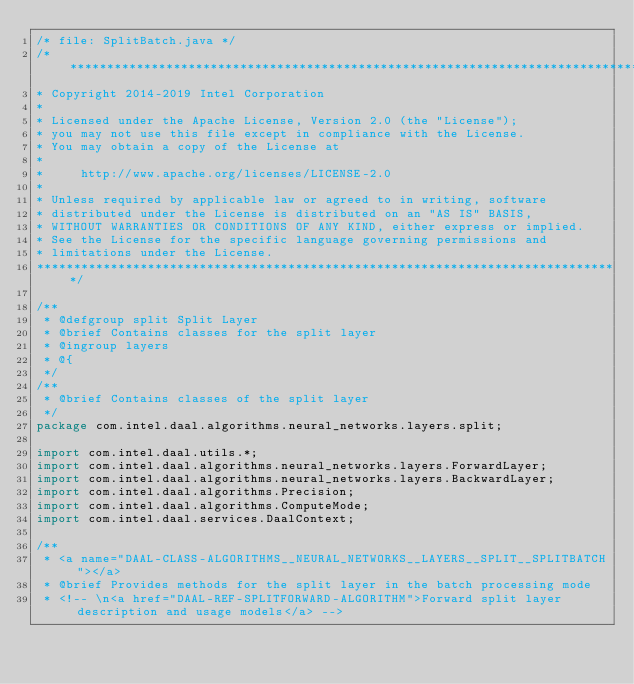<code> <loc_0><loc_0><loc_500><loc_500><_Java_>/* file: SplitBatch.java */
/*******************************************************************************
* Copyright 2014-2019 Intel Corporation
*
* Licensed under the Apache License, Version 2.0 (the "License");
* you may not use this file except in compliance with the License.
* You may obtain a copy of the License at
*
*     http://www.apache.org/licenses/LICENSE-2.0
*
* Unless required by applicable law or agreed to in writing, software
* distributed under the License is distributed on an "AS IS" BASIS,
* WITHOUT WARRANTIES OR CONDITIONS OF ANY KIND, either express or implied.
* See the License for the specific language governing permissions and
* limitations under the License.
*******************************************************************************/

/**
 * @defgroup split Split Layer
 * @brief Contains classes for the split layer
 * @ingroup layers
 * @{
 */
/**
 * @brief Contains classes of the split layer
 */
package com.intel.daal.algorithms.neural_networks.layers.split;

import com.intel.daal.utils.*;
import com.intel.daal.algorithms.neural_networks.layers.ForwardLayer;
import com.intel.daal.algorithms.neural_networks.layers.BackwardLayer;
import com.intel.daal.algorithms.Precision;
import com.intel.daal.algorithms.ComputeMode;
import com.intel.daal.services.DaalContext;

/**
 * <a name="DAAL-CLASS-ALGORITHMS__NEURAL_NETWORKS__LAYERS__SPLIT__SPLITBATCH"></a>
 * @brief Provides methods for the split layer in the batch processing mode
 * <!-- \n<a href="DAAL-REF-SPLITFORWARD-ALGORITHM">Forward split layer description and usage models</a> --></code> 